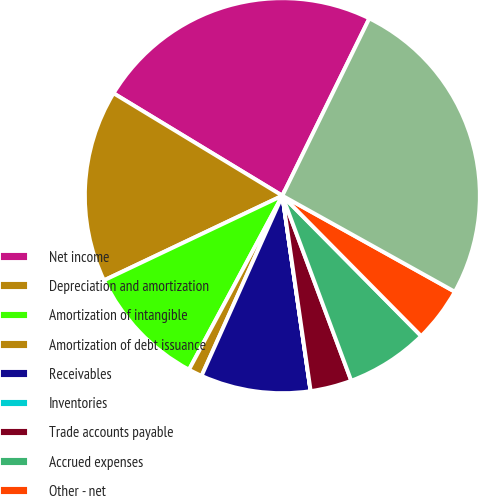Convert chart. <chart><loc_0><loc_0><loc_500><loc_500><pie_chart><fcel>Net income<fcel>Depreciation and amortization<fcel>Amortization of intangible<fcel>Amortization of debt issuance<fcel>Receivables<fcel>Inventories<fcel>Trade accounts payable<fcel>Accrued expenses<fcel>Other - net<fcel>Net cash flows provided by<nl><fcel>23.58%<fcel>15.73%<fcel>10.11%<fcel>1.13%<fcel>8.99%<fcel>0.01%<fcel>3.38%<fcel>6.74%<fcel>4.5%<fcel>25.83%<nl></chart> 